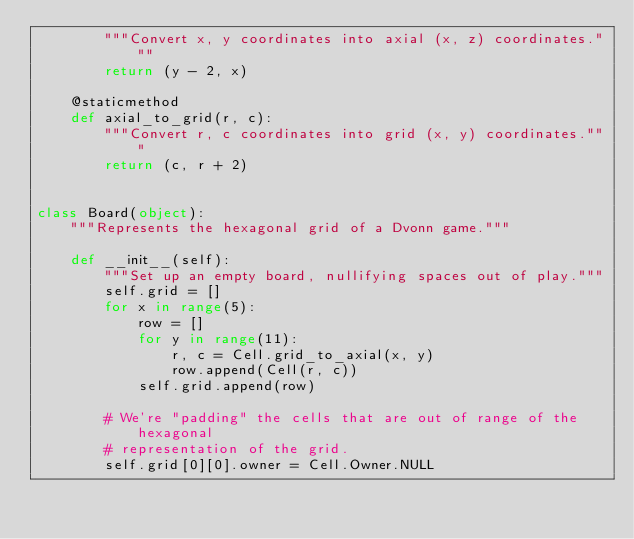<code> <loc_0><loc_0><loc_500><loc_500><_Python_>        """Convert x, y coordinates into axial (x, z) coordinates."""
        return (y - 2, x)

    @staticmethod
    def axial_to_grid(r, c):
        """Convert r, c coordinates into grid (x, y) coordinates."""
        return (c, r + 2)


class Board(object):
    """Represents the hexagonal grid of a Dvonn game."""

    def __init__(self):
        """Set up an empty board, nullifying spaces out of play."""
        self.grid = []
        for x in range(5):
            row = []
            for y in range(11):
                r, c = Cell.grid_to_axial(x, y)
                row.append(Cell(r, c))
            self.grid.append(row)

        # We're "padding" the cells that are out of range of the hexagonal
        # representation of the grid.
        self.grid[0][0].owner = Cell.Owner.NULL</code> 